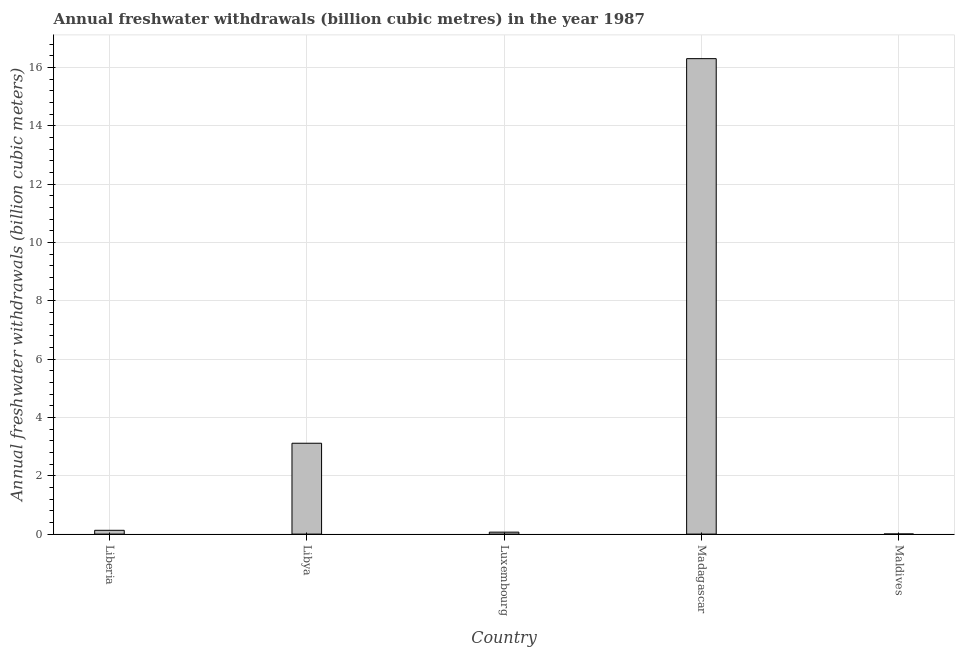Does the graph contain grids?
Your answer should be very brief. Yes. What is the title of the graph?
Provide a short and direct response. Annual freshwater withdrawals (billion cubic metres) in the year 1987. What is the label or title of the X-axis?
Give a very brief answer. Country. What is the label or title of the Y-axis?
Make the answer very short. Annual freshwater withdrawals (billion cubic meters). What is the annual freshwater withdrawals in Maldives?
Provide a succinct answer. 0. Across all countries, what is the maximum annual freshwater withdrawals?
Offer a terse response. 16.3. Across all countries, what is the minimum annual freshwater withdrawals?
Your answer should be compact. 0. In which country was the annual freshwater withdrawals maximum?
Your answer should be very brief. Madagascar. In which country was the annual freshwater withdrawals minimum?
Provide a short and direct response. Maldives. What is the sum of the annual freshwater withdrawals?
Provide a succinct answer. 19.62. What is the difference between the annual freshwater withdrawals in Liberia and Madagascar?
Your answer should be very brief. -16.17. What is the average annual freshwater withdrawals per country?
Ensure brevity in your answer.  3.92. What is the median annual freshwater withdrawals?
Make the answer very short. 0.13. What is the ratio of the annual freshwater withdrawals in Libya to that in Maldives?
Your answer should be compact. 916.18. Is the annual freshwater withdrawals in Liberia less than that in Maldives?
Your response must be concise. No. Is the difference between the annual freshwater withdrawals in Liberia and Maldives greater than the difference between any two countries?
Provide a succinct answer. No. What is the difference between the highest and the second highest annual freshwater withdrawals?
Your response must be concise. 13.19. In how many countries, is the annual freshwater withdrawals greater than the average annual freshwater withdrawals taken over all countries?
Your answer should be very brief. 1. What is the difference between two consecutive major ticks on the Y-axis?
Your answer should be very brief. 2. What is the Annual freshwater withdrawals (billion cubic meters) of Liberia?
Provide a short and direct response. 0.13. What is the Annual freshwater withdrawals (billion cubic meters) of Libya?
Your answer should be compact. 3.12. What is the Annual freshwater withdrawals (billion cubic meters) in Luxembourg?
Your answer should be very brief. 0.07. What is the Annual freshwater withdrawals (billion cubic meters) in Madagascar?
Keep it short and to the point. 16.3. What is the Annual freshwater withdrawals (billion cubic meters) of Maldives?
Make the answer very short. 0. What is the difference between the Annual freshwater withdrawals (billion cubic meters) in Liberia and Libya?
Give a very brief answer. -2.98. What is the difference between the Annual freshwater withdrawals (billion cubic meters) in Liberia and Luxembourg?
Make the answer very short. 0.06. What is the difference between the Annual freshwater withdrawals (billion cubic meters) in Liberia and Madagascar?
Your answer should be compact. -16.17. What is the difference between the Annual freshwater withdrawals (billion cubic meters) in Liberia and Maldives?
Offer a terse response. 0.13. What is the difference between the Annual freshwater withdrawals (billion cubic meters) in Libya and Luxembourg?
Provide a short and direct response. 3.05. What is the difference between the Annual freshwater withdrawals (billion cubic meters) in Libya and Madagascar?
Offer a terse response. -13.19. What is the difference between the Annual freshwater withdrawals (billion cubic meters) in Libya and Maldives?
Your answer should be compact. 3.11. What is the difference between the Annual freshwater withdrawals (billion cubic meters) in Luxembourg and Madagascar?
Offer a terse response. -16.23. What is the difference between the Annual freshwater withdrawals (billion cubic meters) in Luxembourg and Maldives?
Your response must be concise. 0.06. What is the difference between the Annual freshwater withdrawals (billion cubic meters) in Madagascar and Maldives?
Your answer should be compact. 16.3. What is the ratio of the Annual freshwater withdrawals (billion cubic meters) in Liberia to that in Libya?
Your answer should be compact. 0.04. What is the ratio of the Annual freshwater withdrawals (billion cubic meters) in Liberia to that in Luxembourg?
Give a very brief answer. 1.94. What is the ratio of the Annual freshwater withdrawals (billion cubic meters) in Liberia to that in Madagascar?
Provide a short and direct response. 0.01. What is the ratio of the Annual freshwater withdrawals (billion cubic meters) in Liberia to that in Maldives?
Keep it short and to the point. 38.23. What is the ratio of the Annual freshwater withdrawals (billion cubic meters) in Libya to that in Luxembourg?
Provide a succinct answer. 46.49. What is the ratio of the Annual freshwater withdrawals (billion cubic meters) in Libya to that in Madagascar?
Your answer should be compact. 0.19. What is the ratio of the Annual freshwater withdrawals (billion cubic meters) in Libya to that in Maldives?
Offer a terse response. 916.18. What is the ratio of the Annual freshwater withdrawals (billion cubic meters) in Luxembourg to that in Madagascar?
Your answer should be compact. 0. What is the ratio of the Annual freshwater withdrawals (billion cubic meters) in Luxembourg to that in Maldives?
Your response must be concise. 19.71. What is the ratio of the Annual freshwater withdrawals (billion cubic meters) in Madagascar to that in Maldives?
Provide a short and direct response. 4794.12. 